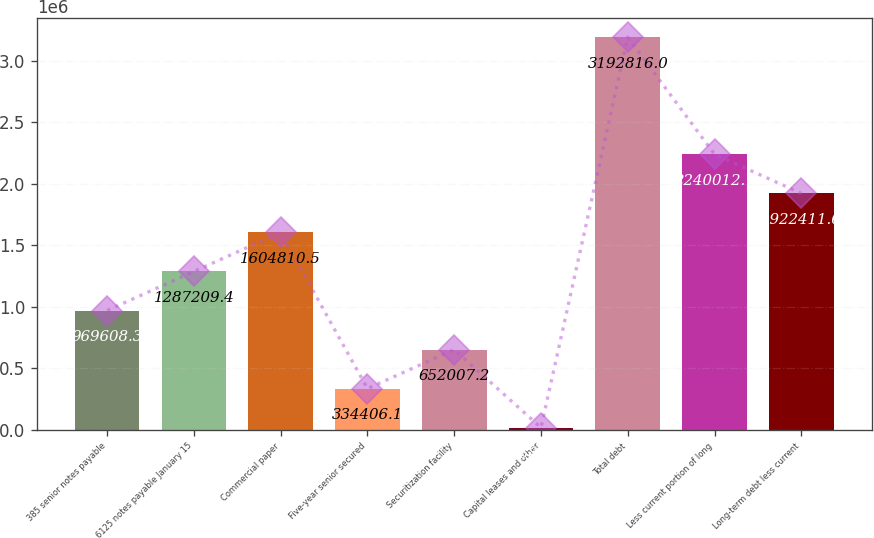<chart> <loc_0><loc_0><loc_500><loc_500><bar_chart><fcel>385 senior notes payable<fcel>6125 notes payable January 15<fcel>Commercial paper<fcel>Five-year senior secured<fcel>Securitization facility<fcel>Capital leases and other<fcel>Total debt<fcel>Less current portion of long<fcel>Long-term debt less current<nl><fcel>969608<fcel>1.28721e+06<fcel>1.60481e+06<fcel>334406<fcel>652007<fcel>16805<fcel>3.19282e+06<fcel>2.24001e+06<fcel>1.92241e+06<nl></chart> 